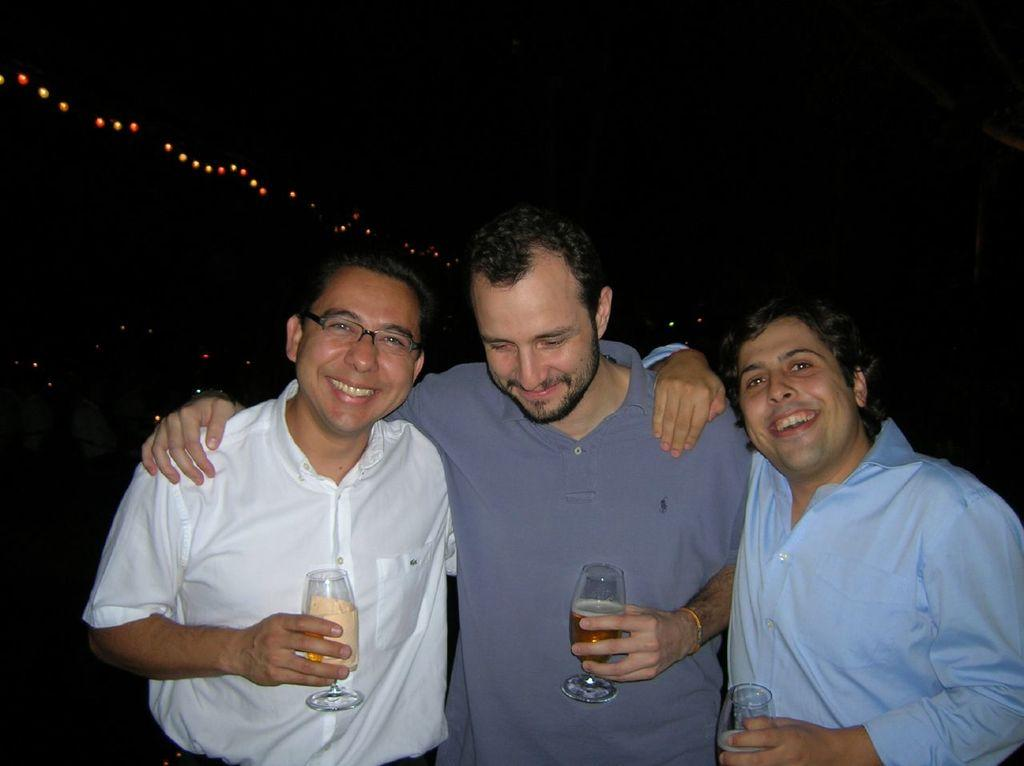How many people are in the image? There are three men in the image. What are the men doing in the image? The men are standing and holding glasses. What expressions do the men have in the image? The men are smiling in the image. What is the color of the background in the image? The background of the image is dark. What can be seen in the background of the image? There are lights visible in the background. What type of door can be seen in the image? There is no door present in the image. What caused the men to smile in the image? The cause of the men's smiles is not visible or mentioned in the image. 